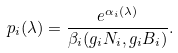Convert formula to latex. <formula><loc_0><loc_0><loc_500><loc_500>p _ { i } ( \lambda ) = \frac { e ^ { \alpha _ { i } ( \lambda ) } } { \beta _ { i } ( g _ { i } N _ { i } , g _ { i } B _ { i } ) } .</formula> 